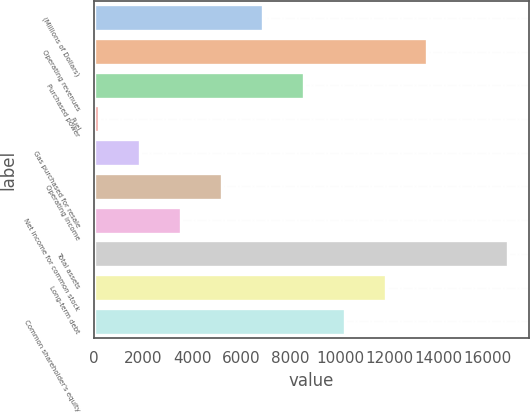<chart> <loc_0><loc_0><loc_500><loc_500><bar_chart><fcel>(Millions of Dollars)<fcel>Operating revenues<fcel>Purchased power<fcel>Fuel<fcel>Gas purchased for resale<fcel>Operating income<fcel>Net income for common stock<fcel>Total assets<fcel>Long-term debt<fcel>Common shareholder's equity<nl><fcel>6874<fcel>13516<fcel>8534.5<fcel>232<fcel>1892.5<fcel>5213.5<fcel>3553<fcel>16837<fcel>11855.5<fcel>10195<nl></chart> 